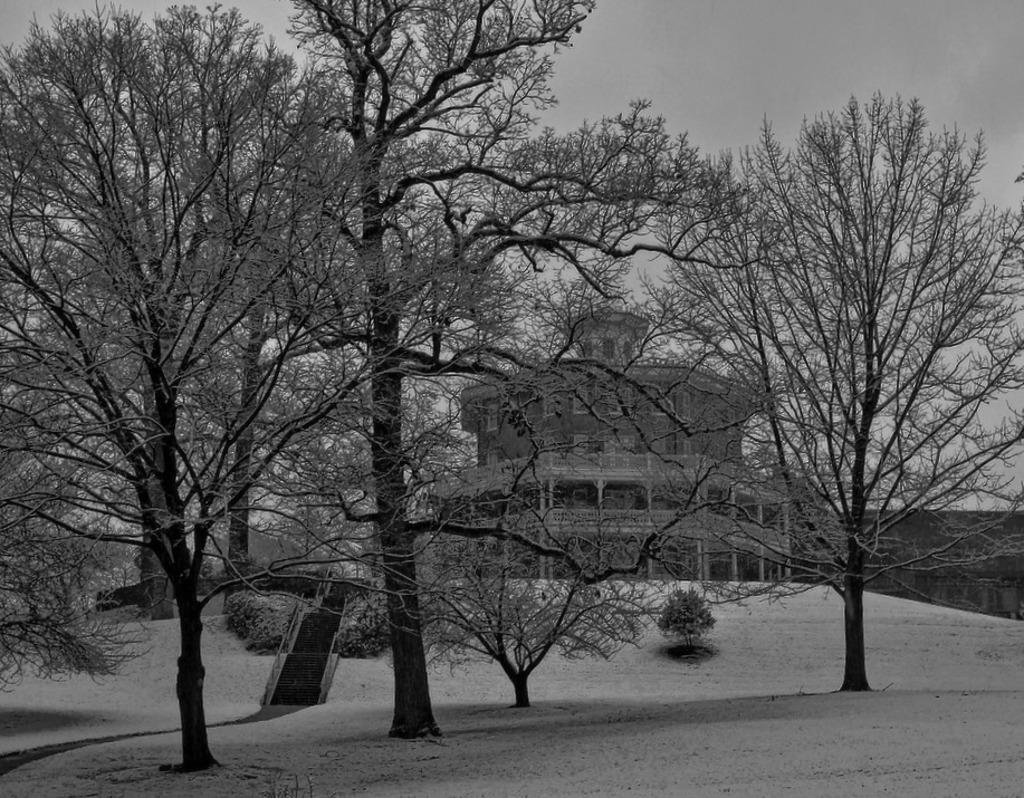What type of natural elements can be seen in the image? There are trees in the image. What type of man-made structure is visible in the image? There is a building in the image. What is the color scheme of the image? The image is in black and white. What type of dinner is being served in the image? There is no dinner present in the image; it features trees and a building in black and white. How does the wealth of the toad in the image compare to that of the other toads in the area? There are no toads present in the image, so it is not possible to compare their wealth. 